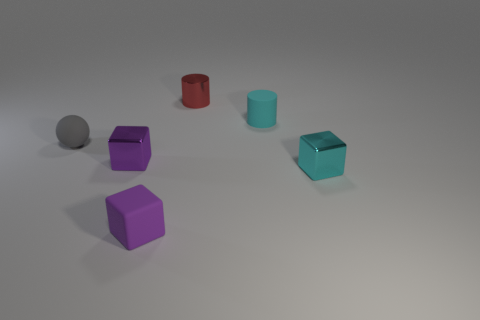Subtract all red cubes. Subtract all brown balls. How many cubes are left? 3 Add 2 purple shiny cubes. How many objects exist? 8 Subtract all balls. How many objects are left? 5 Add 6 tiny brown metal blocks. How many tiny brown metal blocks exist? 6 Subtract 0 gray blocks. How many objects are left? 6 Subtract all tiny purple metallic objects. Subtract all spheres. How many objects are left? 4 Add 6 purple things. How many purple things are left? 8 